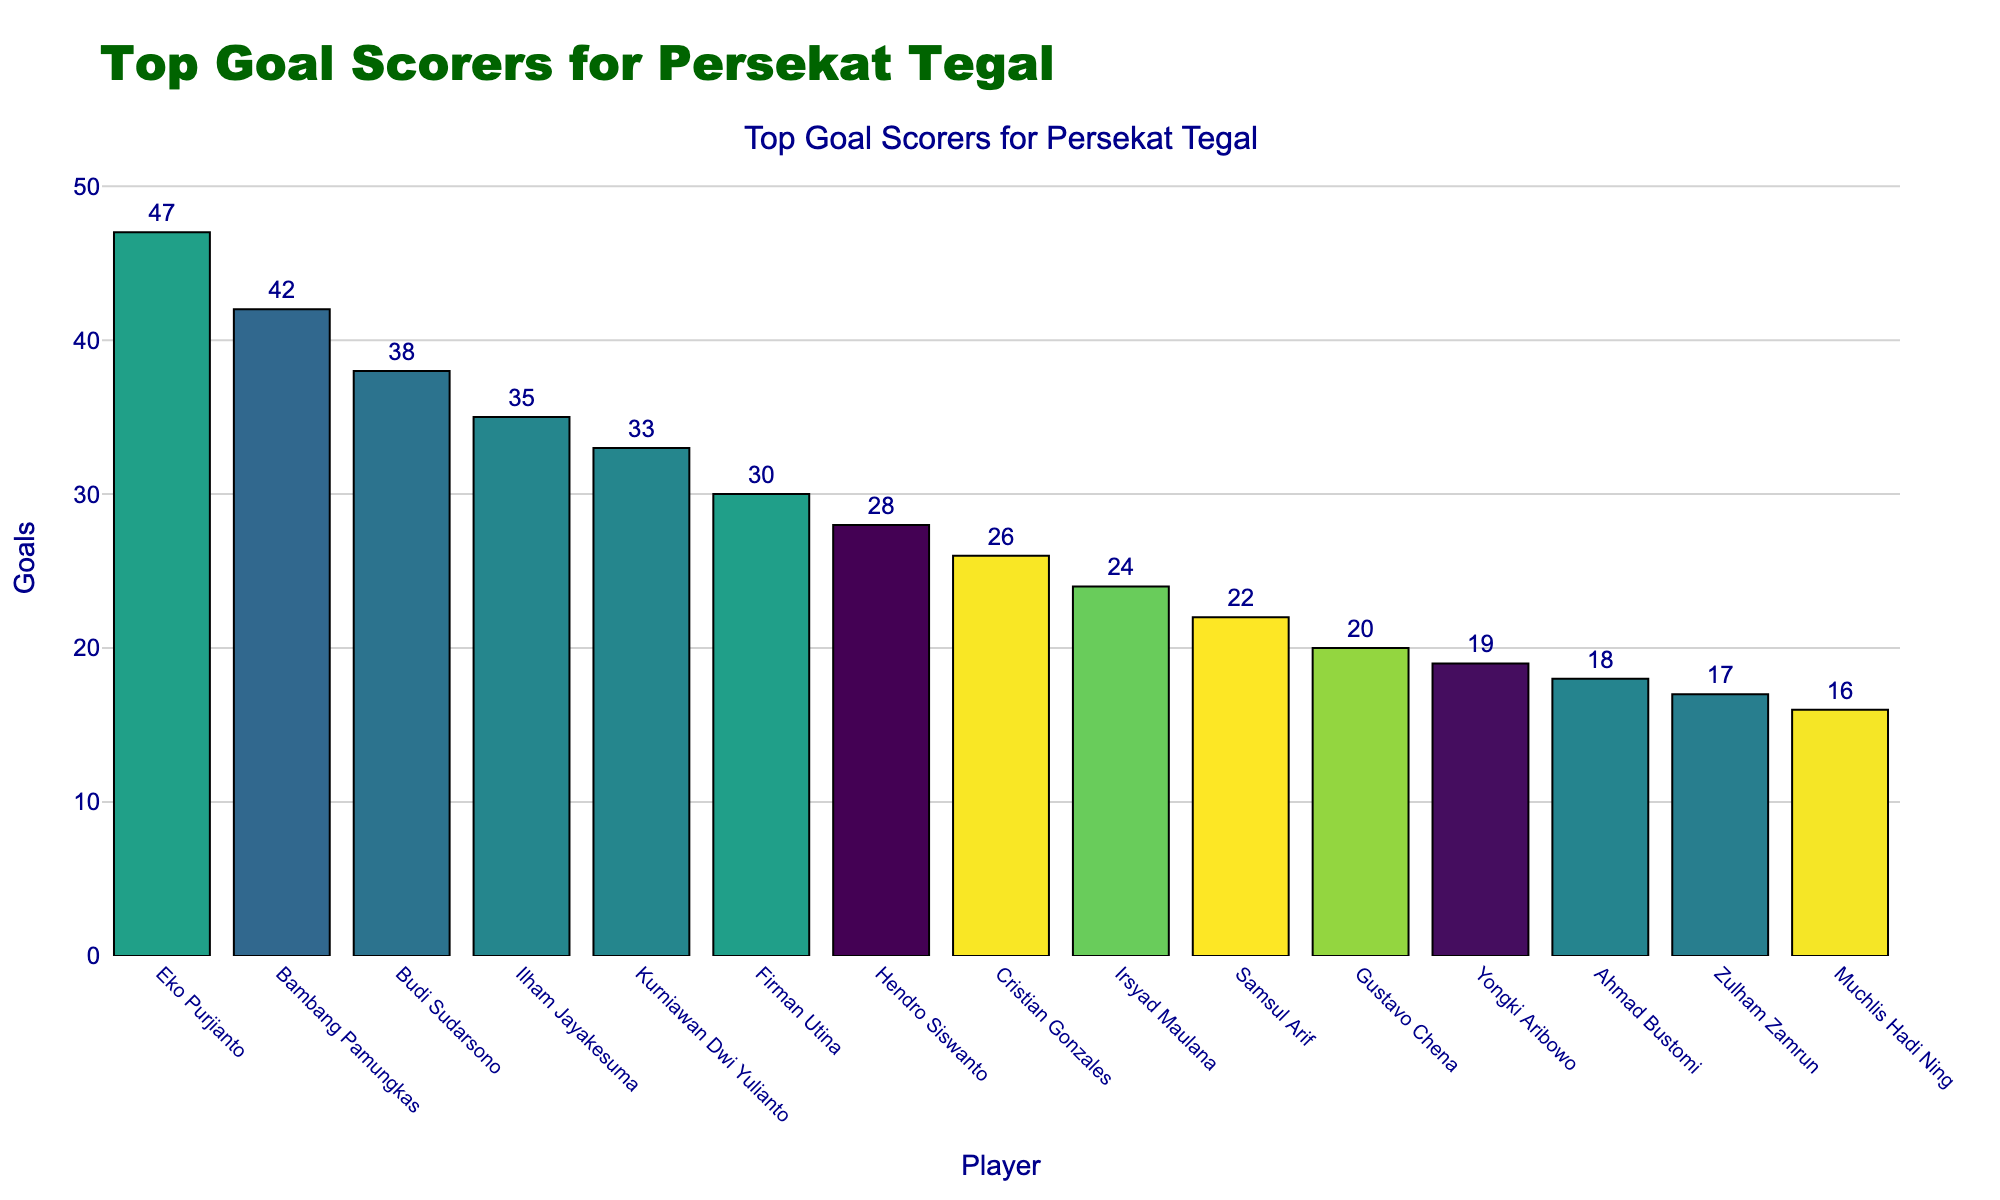Who is the top goal scorer for Persekat Tegal in the last 10 seasons? The bar with the greatest height in the chart corresponds to Eko Purjianto, indicating he has the most goals.
Answer: Eko Purjianto How many goals did Bambang Pamungkas score? Find Bambang Pamungkas on the x-axis and check the height of his bar which is labeled with the number of goals.
Answer: 42 What is the combined total number of goals scored by Eko Purjianto and Budi Sudarsono? Eko Purjianto scored 47 goals and Budi Sudarsono scored 38 goals. Summing these values, 47 + 38, gives 85.
Answer: 85 Who has more goals, Cristian Gonzales or Hendro Siswanto, and by how many? Compare the number of goals of Cristian Gonzales (26) and Hendro Siswanto (28). Hendro Siswanto has 2 more goals than Cristian Gonzales.
Answer: Hendro Siswanto by 2 goals What is the difference in goals between Firman Utina and Kurniawan Dwi Yulianto? Subtract the number of goals of Firman Utina (30) from that of Kurniawan Dwi Yulianto (33). The difference is 3.
Answer: 3 Which player has the lowest number of goals and how many? Identify the player with the least height on the bar chart, which corresponds to Muchlis Hadi Ning with 16 goals.
Answer: Muchlis Hadi Ning, 16 goals How many players scored at least 30 goals in the last 10 seasons? Count the number of bars with heights reaching 30 or more goals: Eko Purjianto, Bambang Pamungkas, Budi Sudarsono, Ilham Jayakesuma, Kurniawan Dwi Yulianto, and Firman Utina. There are 6 players.
Answer: 6 What is the average number of goals scored by the top three goal scorers? Sum the goals of the top three scorers: Eko Purjianto (47), Bambang Pamungkas (42), Budi Sudarsono (38). The total is 127. The average is 127 / 3, which is approximately 42.33.
Answer: 42.33 How many more goals did Ilham Jayakesuma score compared to Zulham Zamrun? Ilham Jayakesuma scored 35 goals, and Zulham Zamrun scored 17 goals. Subtracting, 35 - 17, gives 18.
Answer: 18 What is the total number of goals scored by players who have fewer than 25 goals? Sum the goals of players with fewer than 25 goals: Christian Gonzales (26), Irsyad Maulana (24), Samsul Arif (22), Gustavo Chena (20), Yongki Aribowo (19), Ahmad Bustomi (18), Zulham Zamrun (17), Muchlis Hadi Ning (16). The total sum is 170.
Answer: 170 